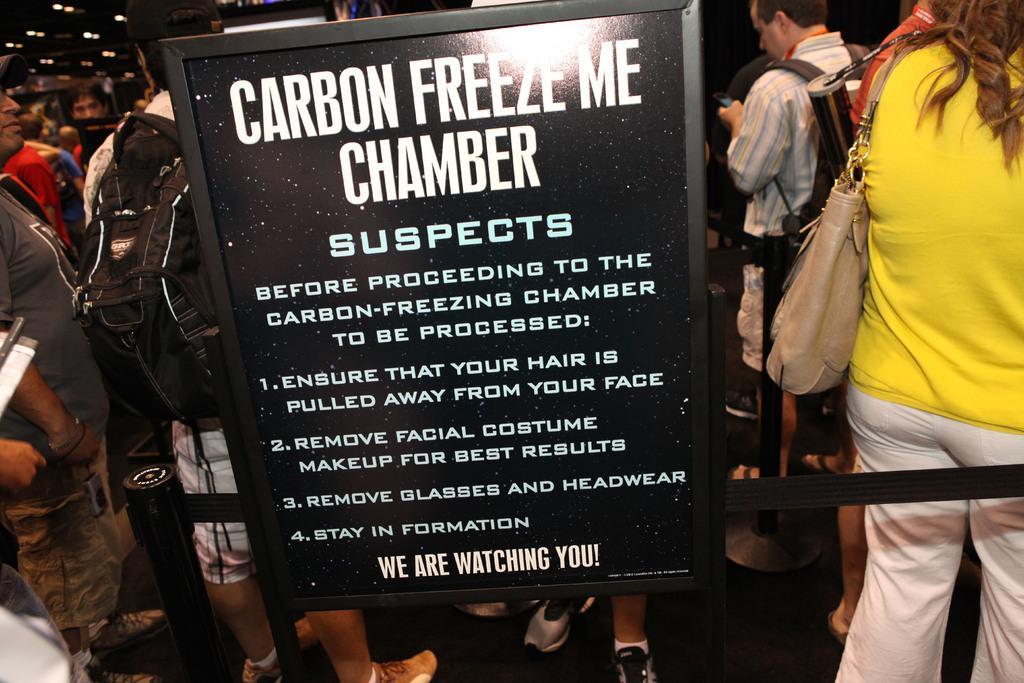Please provide a concise description of this image. Here in this picture we can see a board present on the floor over there and on that board we can see some text present and we can also see number of people standing and walking on the floor over there and most of them are carrying handbags and bags with them and on the roof we can see lights present over there. 